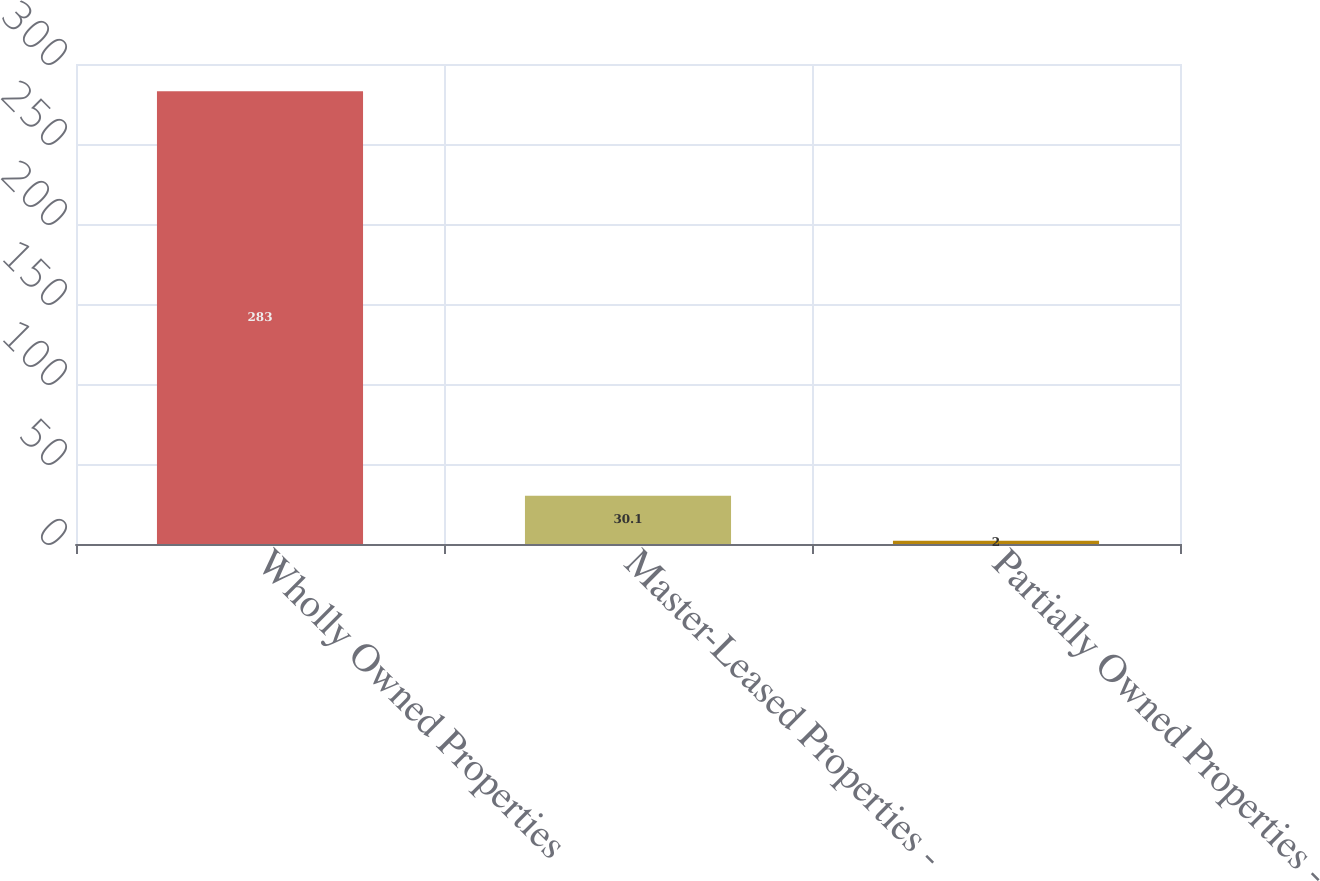Convert chart. <chart><loc_0><loc_0><loc_500><loc_500><bar_chart><fcel>Wholly Owned Properties<fcel>Master-Leased Properties -<fcel>Partially Owned Properties -<nl><fcel>283<fcel>30.1<fcel>2<nl></chart> 